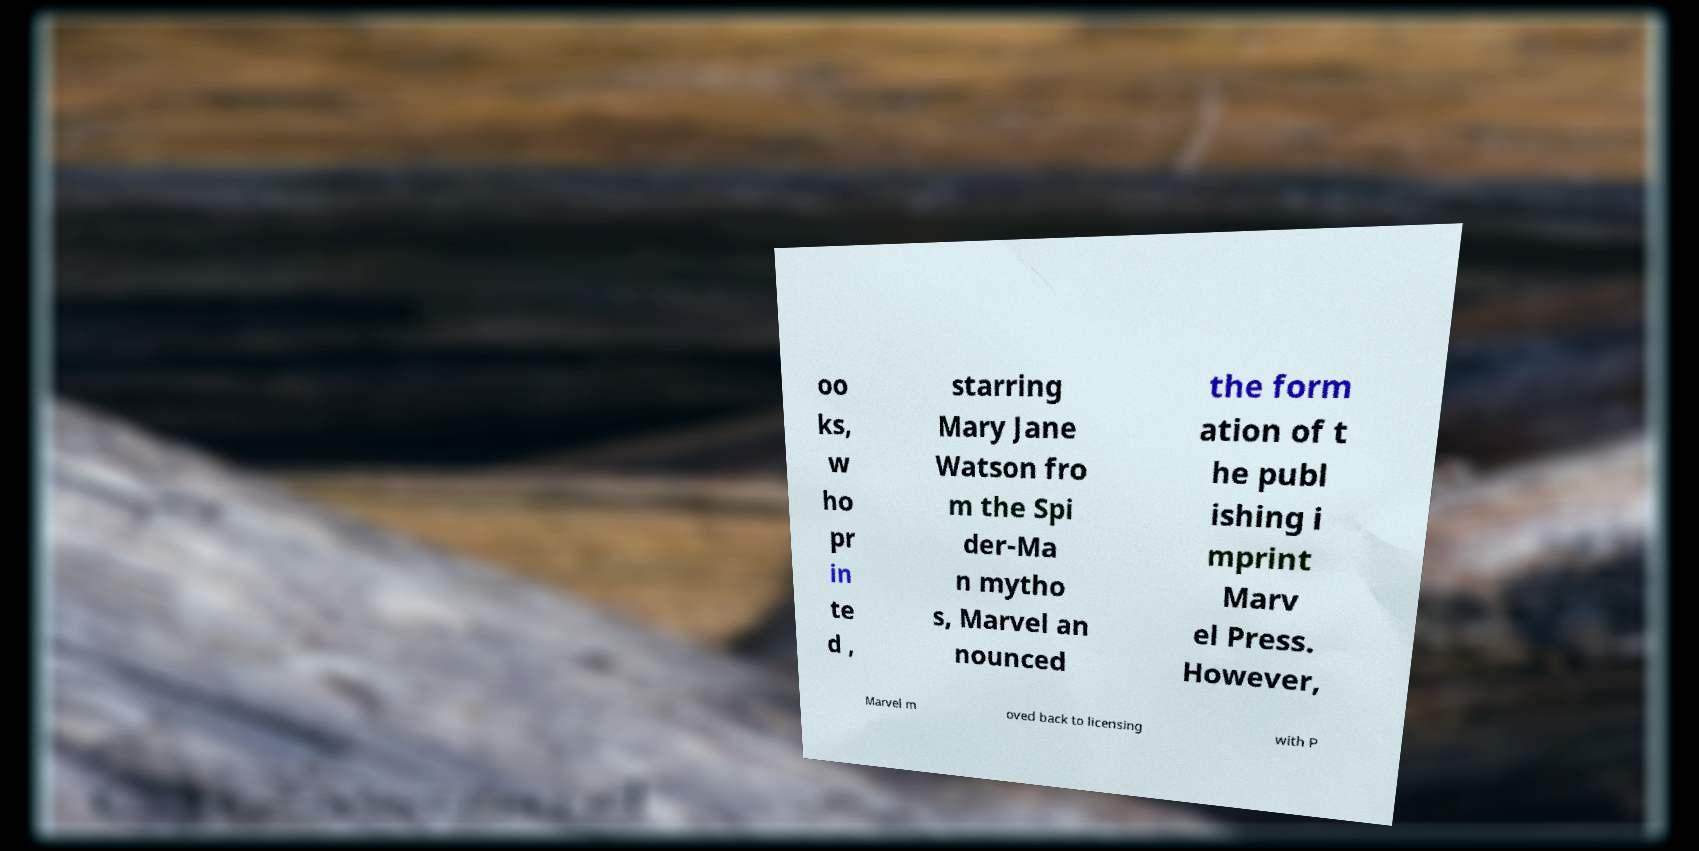Please read and relay the text visible in this image. What does it say? oo ks, w ho pr in te d , starring Mary Jane Watson fro m the Spi der-Ma n mytho s, Marvel an nounced the form ation of t he publ ishing i mprint Marv el Press. However, Marvel m oved back to licensing with P 